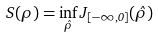Convert formula to latex. <formula><loc_0><loc_0><loc_500><loc_500>S ( \rho ) = \inf _ { \hat { \rho } } J _ { [ - \infty , 0 ] } ( \hat { \rho } )</formula> 